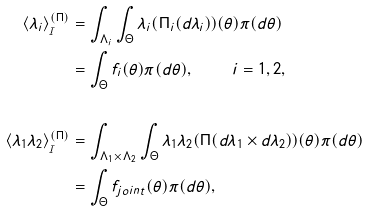<formula> <loc_0><loc_0><loc_500><loc_500>\langle \lambda _ { i } \rangle _ { _ { \mathcal { I } } } ^ { ( \Pi ) } & = \int _ { \Lambda _ { i } } \int _ { \Theta } \lambda _ { i } ( \Pi _ { i } ( d \lambda _ { i } ) ) ( \theta ) \pi ( d \theta ) \\ & = \int _ { \Theta } f _ { i } ( \theta ) \pi ( d \theta ) , \text { \quad \ } \ \ i = 1 , 2 , \\ & \\ \langle \lambda _ { 1 } \lambda _ { 2 } \rangle _ { _ { \mathcal { I } } } ^ { ( \Pi ) } & = \int _ { \Lambda _ { 1 } \times \Lambda _ { 2 } } \int _ { \Theta } \lambda _ { 1 } \lambda _ { 2 } ( \Pi ( d \lambda _ { 1 } \times d \lambda _ { 2 } ) ) ( \theta ) \pi ( d \theta ) \\ & = \int _ { \Theta } f _ { j o i n t } ( \theta ) \pi ( d \theta ) ,</formula> 